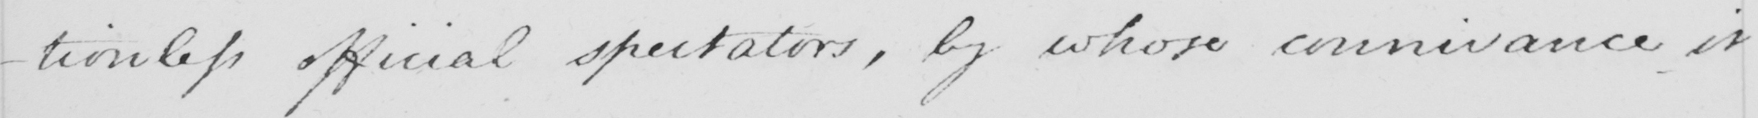What text is written in this handwritten line? -tionless official spectators , by whose connivance it 